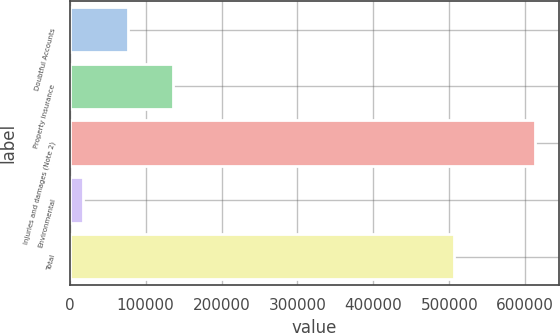Convert chart. <chart><loc_0><loc_0><loc_500><loc_500><bar_chart><fcel>Doubtful Accounts<fcel>Property insurance<fcel>Injuries and damages (Note 2)<fcel>Environmental<fcel>Total<nl><fcel>77037.5<fcel>136637<fcel>613433<fcel>17438<fcel>506746<nl></chart> 